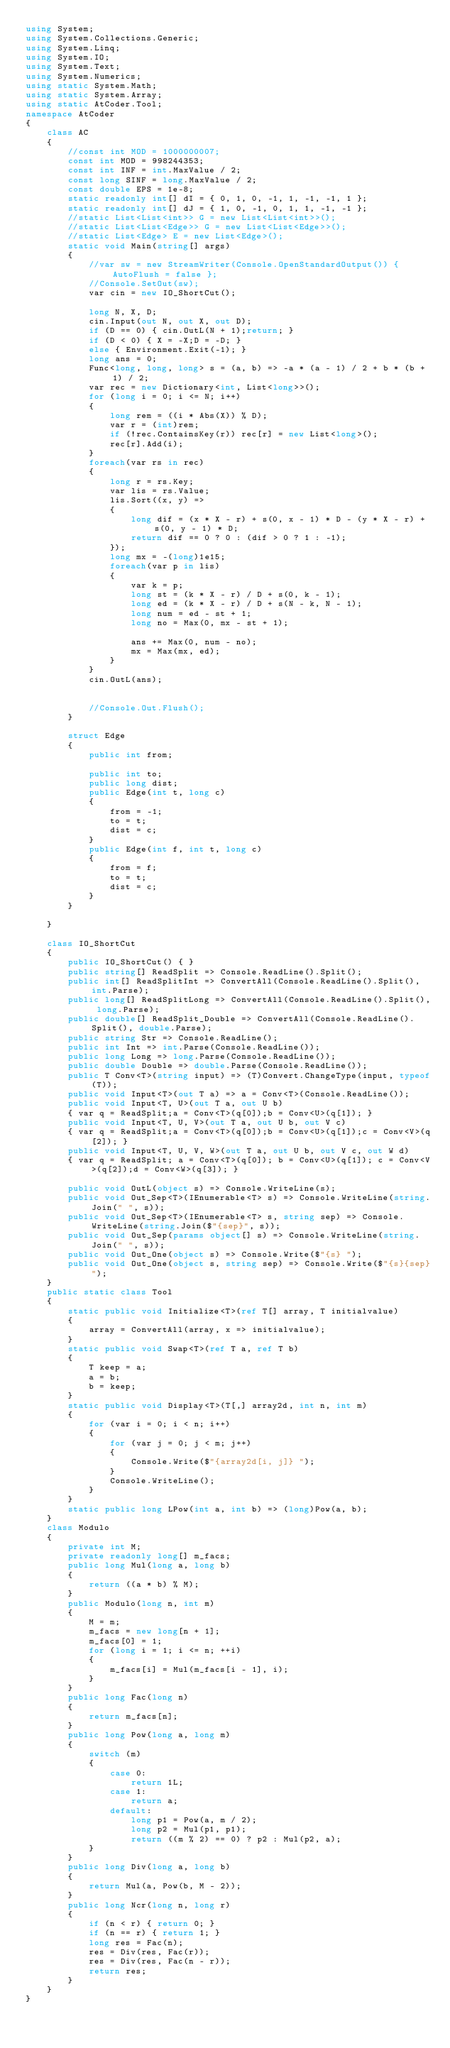Convert code to text. <code><loc_0><loc_0><loc_500><loc_500><_C#_>using System;
using System.Collections.Generic;
using System.Linq;
using System.IO;
using System.Text;
using System.Numerics;
using static System.Math;
using static System.Array;
using static AtCoder.Tool;
namespace AtCoder
{
    class AC
    {
        //const int MOD = 1000000007;
        const int MOD = 998244353;
        const int INF = int.MaxValue / 2;
        const long SINF = long.MaxValue / 2;
        const double EPS = 1e-8;
        static readonly int[] dI = { 0, 1, 0, -1, 1, -1, -1, 1 };
        static readonly int[] dJ = { 1, 0, -1, 0, 1, 1, -1, -1 };
        //static List<List<int>> G = new List<List<int>>();
        //static List<List<Edge>> G = new List<List<Edge>>();
        //static List<Edge> E = new List<Edge>();
        static void Main(string[] args)
        {
            //var sw = new StreamWriter(Console.OpenStandardOutput()) { AutoFlush = false };
            //Console.SetOut(sw);
            var cin = new IO_ShortCut();

            long N, X, D;
            cin.Input(out N, out X, out D);
            if (D == 0) { cin.OutL(N + 1);return; }
            if (D < 0) { X = -X;D = -D; }
            else { Environment.Exit(-1); }
            long ans = 0;
            Func<long, long, long> s = (a, b) => -a * (a - 1) / 2 + b * (b + 1) / 2;
            var rec = new Dictionary<int, List<long>>();
            for (long i = 0; i <= N; i++)
            {
                long rem = ((i * Abs(X)) % D);
                var r = (int)rem;
                if (!rec.ContainsKey(r)) rec[r] = new List<long>();
                rec[r].Add(i);
            }
            foreach(var rs in rec)
            {
                long r = rs.Key;
                var lis = rs.Value;
                lis.Sort((x, y) =>
                {
                    long dif = (x * X - r) + s(0, x - 1) * D - (y * X - r) + s(0, y - 1) * D;
                    return dif == 0 ? 0 : (dif > 0 ? 1 : -1);
                });
                long mx = -(long)1e15;
                foreach(var p in lis)
                {
                    var k = p;
                    long st = (k * X - r) / D + s(0, k - 1);
                    long ed = (k * X - r) / D + s(N - k, N - 1);
                    long num = ed - st + 1;
                    long no = Max(0, mx - st + 1);

                    ans += Max(0, num - no);
                    mx = Max(mx, ed);
                }
            }
            cin.OutL(ans);


            //Console.Out.Flush();
        }
        
        struct Edge
        {
            public int from;

            public int to;
            public long dist;
            public Edge(int t, long c)
            {
                from = -1;
                to = t;
                dist = c;
            }
            public Edge(int f, int t, long c)
            {
                from = f;
                to = t;
                dist = c;
            }
        }
        
    }
    
    class IO_ShortCut
    {
        public IO_ShortCut() { }
        public string[] ReadSplit => Console.ReadLine().Split();
        public int[] ReadSplitInt => ConvertAll(Console.ReadLine().Split(), int.Parse);
        public long[] ReadSplitLong => ConvertAll(Console.ReadLine().Split(), long.Parse);
        public double[] ReadSplit_Double => ConvertAll(Console.ReadLine().Split(), double.Parse);
        public string Str => Console.ReadLine();
        public int Int => int.Parse(Console.ReadLine());
        public long Long => long.Parse(Console.ReadLine());
        public double Double => double.Parse(Console.ReadLine());
        public T Conv<T>(string input) => (T)Convert.ChangeType(input, typeof(T));
        public void Input<T>(out T a) => a = Conv<T>(Console.ReadLine());
        public void Input<T, U>(out T a, out U b)
        { var q = ReadSplit;a = Conv<T>(q[0]);b = Conv<U>(q[1]); }
        public void Input<T, U, V>(out T a, out U b, out V c)
        { var q = ReadSplit;a = Conv<T>(q[0]);b = Conv<U>(q[1]);c = Conv<V>(q[2]); }
        public void Input<T, U, V, W>(out T a, out U b, out V c, out W d)
        { var q = ReadSplit; a = Conv<T>(q[0]); b = Conv<U>(q[1]); c = Conv<V>(q[2]);d = Conv<W>(q[3]); }

        public void OutL(object s) => Console.WriteLine(s);
        public void Out_Sep<T>(IEnumerable<T> s) => Console.WriteLine(string.Join(" ", s));
        public void Out_Sep<T>(IEnumerable<T> s, string sep) => Console.WriteLine(string.Join($"{sep}", s));
        public void Out_Sep(params object[] s) => Console.WriteLine(string.Join(" ", s));
        public void Out_One(object s) => Console.Write($"{s} ");
        public void Out_One(object s, string sep) => Console.Write($"{s}{sep}");
    }
    public static class Tool
    {
        static public void Initialize<T>(ref T[] array, T initialvalue)
        {
            array = ConvertAll(array, x => initialvalue);
        }
        static public void Swap<T>(ref T a, ref T b)
        {
            T keep = a;
            a = b;
            b = keep;
        }
        static public void Display<T>(T[,] array2d, int n, int m)
        {
            for (var i = 0; i < n; i++)
            {
                for (var j = 0; j < m; j++)
                {
                    Console.Write($"{array2d[i, j]} ");
                }
                Console.WriteLine();
            }
        }
        static public long LPow(int a, int b) => (long)Pow(a, b);
    }
    class Modulo
    {
        private int M;
        private readonly long[] m_facs;
        public long Mul(long a, long b)
        {
            return ((a * b) % M);
        }
        public Modulo(long n, int m)
        {
            M = m;
            m_facs = new long[n + 1];
            m_facs[0] = 1;
            for (long i = 1; i <= n; ++i)
            {
                m_facs[i] = Mul(m_facs[i - 1], i);
            }
        }
        public long Fac(long n)
        {
            return m_facs[n];
        }
        public long Pow(long a, long m)
        {
            switch (m)
            {
                case 0:
                    return 1L;
                case 1:
                    return a;
                default:
                    long p1 = Pow(a, m / 2);
                    long p2 = Mul(p1, p1);
                    return ((m % 2) == 0) ? p2 : Mul(p2, a);
            }
        }
        public long Div(long a, long b)
        {
            return Mul(a, Pow(b, M - 2));
        }
        public long Ncr(long n, long r)
        {
            if (n < r) { return 0; }
            if (n == r) { return 1; }
            long res = Fac(n);
            res = Div(res, Fac(r));
            res = Div(res, Fac(n - r));
            return res;
        }
    }
}
</code> 